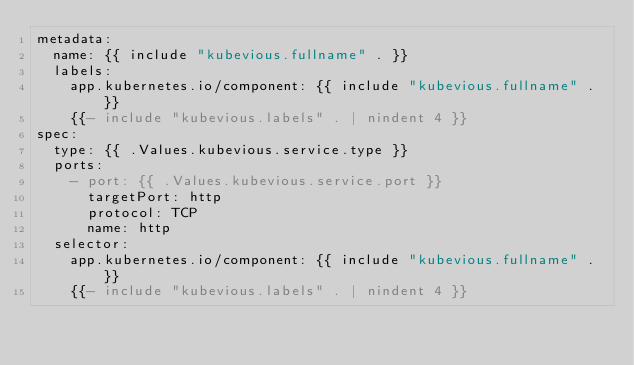<code> <loc_0><loc_0><loc_500><loc_500><_YAML_>metadata:
  name: {{ include "kubevious.fullname" . }}
  labels:
    app.kubernetes.io/component: {{ include "kubevious.fullname" . }}
    {{- include "kubevious.labels" . | nindent 4 }}
spec:
  type: {{ .Values.kubevious.service.type }}
  ports:
    - port: {{ .Values.kubevious.service.port }}
      targetPort: http
      protocol: TCP
      name: http
  selector:
    app.kubernetes.io/component: {{ include "kubevious.fullname" . }}
    {{- include "kubevious.labels" . | nindent 4 }}
</code> 